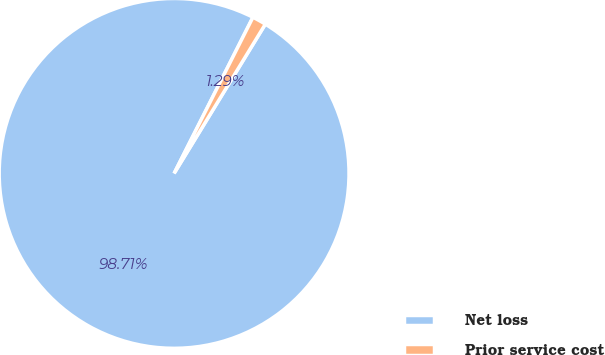<chart> <loc_0><loc_0><loc_500><loc_500><pie_chart><fcel>Net loss<fcel>Prior service cost<nl><fcel>98.71%<fcel>1.29%<nl></chart> 